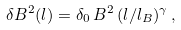<formula> <loc_0><loc_0><loc_500><loc_500>\delta B ^ { 2 } ( l ) = \delta _ { 0 } \, B ^ { 2 } \, ( l / l _ { B } ) ^ { \gamma } \, ,</formula> 